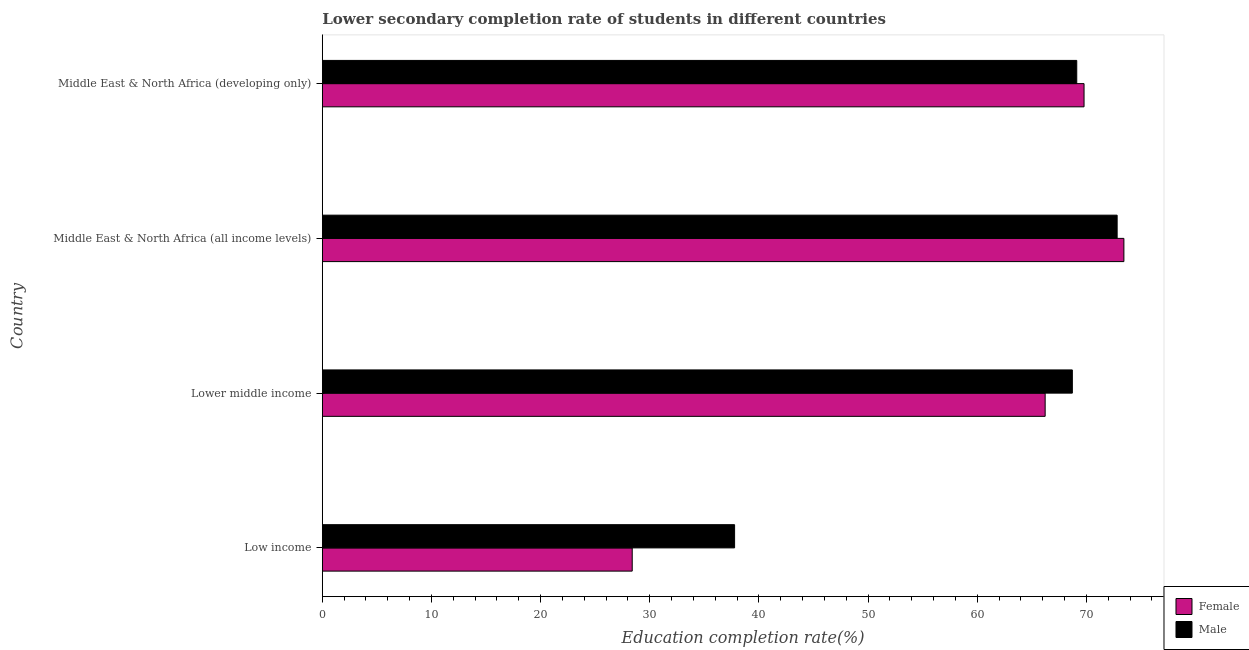Are the number of bars per tick equal to the number of legend labels?
Ensure brevity in your answer.  Yes. Are the number of bars on each tick of the Y-axis equal?
Your response must be concise. Yes. How many bars are there on the 4th tick from the bottom?
Provide a short and direct response. 2. What is the label of the 1st group of bars from the top?
Offer a very short reply. Middle East & North Africa (developing only). What is the education completion rate of female students in Middle East & North Africa (all income levels)?
Provide a succinct answer. 73.44. Across all countries, what is the maximum education completion rate of female students?
Make the answer very short. 73.44. Across all countries, what is the minimum education completion rate of male students?
Your answer should be compact. 37.77. In which country was the education completion rate of female students maximum?
Keep it short and to the point. Middle East & North Africa (all income levels). In which country was the education completion rate of female students minimum?
Your response must be concise. Low income. What is the total education completion rate of male students in the graph?
Keep it short and to the point. 248.42. What is the difference between the education completion rate of female students in Lower middle income and that in Middle East & North Africa (all income levels)?
Your response must be concise. -7.21. What is the difference between the education completion rate of female students in Middle East & North Africa (all income levels) and the education completion rate of male students in Low income?
Make the answer very short. 35.67. What is the average education completion rate of female students per country?
Make the answer very short. 59.46. What is the difference between the education completion rate of male students and education completion rate of female students in Lower middle income?
Make the answer very short. 2.49. What is the ratio of the education completion rate of male students in Middle East & North Africa (all income levels) to that in Middle East & North Africa (developing only)?
Give a very brief answer. 1.05. Is the education completion rate of male students in Middle East & North Africa (all income levels) less than that in Middle East & North Africa (developing only)?
Your answer should be very brief. No. Is the difference between the education completion rate of male students in Middle East & North Africa (all income levels) and Middle East & North Africa (developing only) greater than the difference between the education completion rate of female students in Middle East & North Africa (all income levels) and Middle East & North Africa (developing only)?
Give a very brief answer. Yes. What is the difference between the highest and the second highest education completion rate of female students?
Make the answer very short. 3.65. What is the difference between the highest and the lowest education completion rate of male students?
Offer a very short reply. 35.05. What does the 2nd bar from the bottom in Middle East & North Africa (all income levels) represents?
Your answer should be compact. Male. How many bars are there?
Ensure brevity in your answer.  8. Are the values on the major ticks of X-axis written in scientific E-notation?
Your answer should be very brief. No. Where does the legend appear in the graph?
Your answer should be very brief. Bottom right. How many legend labels are there?
Offer a very short reply. 2. How are the legend labels stacked?
Provide a succinct answer. Vertical. What is the title of the graph?
Make the answer very short. Lower secondary completion rate of students in different countries. Does "Investment in Transport" appear as one of the legend labels in the graph?
Your answer should be compact. No. What is the label or title of the X-axis?
Keep it short and to the point. Education completion rate(%). What is the label or title of the Y-axis?
Keep it short and to the point. Country. What is the Education completion rate(%) in Female in Low income?
Ensure brevity in your answer.  28.39. What is the Education completion rate(%) in Male in Low income?
Offer a very short reply. 37.77. What is the Education completion rate(%) of Female in Lower middle income?
Give a very brief answer. 66.22. What is the Education completion rate(%) of Male in Lower middle income?
Your response must be concise. 68.71. What is the Education completion rate(%) of Female in Middle East & North Africa (all income levels)?
Keep it short and to the point. 73.44. What is the Education completion rate(%) of Male in Middle East & North Africa (all income levels)?
Keep it short and to the point. 72.82. What is the Education completion rate(%) of Female in Middle East & North Africa (developing only)?
Your response must be concise. 69.78. What is the Education completion rate(%) in Male in Middle East & North Africa (developing only)?
Ensure brevity in your answer.  69.12. Across all countries, what is the maximum Education completion rate(%) in Female?
Provide a short and direct response. 73.44. Across all countries, what is the maximum Education completion rate(%) of Male?
Your answer should be compact. 72.82. Across all countries, what is the minimum Education completion rate(%) of Female?
Provide a short and direct response. 28.39. Across all countries, what is the minimum Education completion rate(%) of Male?
Make the answer very short. 37.77. What is the total Education completion rate(%) of Female in the graph?
Keep it short and to the point. 237.83. What is the total Education completion rate(%) in Male in the graph?
Ensure brevity in your answer.  248.42. What is the difference between the Education completion rate(%) of Female in Low income and that in Lower middle income?
Make the answer very short. -37.83. What is the difference between the Education completion rate(%) in Male in Low income and that in Lower middle income?
Provide a short and direct response. -30.94. What is the difference between the Education completion rate(%) in Female in Low income and that in Middle East & North Africa (all income levels)?
Give a very brief answer. -45.05. What is the difference between the Education completion rate(%) in Male in Low income and that in Middle East & North Africa (all income levels)?
Your answer should be very brief. -35.05. What is the difference between the Education completion rate(%) in Female in Low income and that in Middle East & North Africa (developing only)?
Make the answer very short. -41.39. What is the difference between the Education completion rate(%) in Male in Low income and that in Middle East & North Africa (developing only)?
Keep it short and to the point. -31.35. What is the difference between the Education completion rate(%) of Female in Lower middle income and that in Middle East & North Africa (all income levels)?
Keep it short and to the point. -7.21. What is the difference between the Education completion rate(%) of Male in Lower middle income and that in Middle East & North Africa (all income levels)?
Provide a short and direct response. -4.1. What is the difference between the Education completion rate(%) of Female in Lower middle income and that in Middle East & North Africa (developing only)?
Give a very brief answer. -3.56. What is the difference between the Education completion rate(%) in Male in Lower middle income and that in Middle East & North Africa (developing only)?
Keep it short and to the point. -0.4. What is the difference between the Education completion rate(%) of Female in Middle East & North Africa (all income levels) and that in Middle East & North Africa (developing only)?
Your answer should be compact. 3.65. What is the difference between the Education completion rate(%) of Male in Middle East & North Africa (all income levels) and that in Middle East & North Africa (developing only)?
Provide a succinct answer. 3.7. What is the difference between the Education completion rate(%) of Female in Low income and the Education completion rate(%) of Male in Lower middle income?
Make the answer very short. -40.32. What is the difference between the Education completion rate(%) of Female in Low income and the Education completion rate(%) of Male in Middle East & North Africa (all income levels)?
Your response must be concise. -44.43. What is the difference between the Education completion rate(%) of Female in Low income and the Education completion rate(%) of Male in Middle East & North Africa (developing only)?
Provide a succinct answer. -40.73. What is the difference between the Education completion rate(%) of Female in Lower middle income and the Education completion rate(%) of Male in Middle East & North Africa (all income levels)?
Your answer should be very brief. -6.6. What is the difference between the Education completion rate(%) in Female in Lower middle income and the Education completion rate(%) in Male in Middle East & North Africa (developing only)?
Provide a short and direct response. -2.89. What is the difference between the Education completion rate(%) in Female in Middle East & North Africa (all income levels) and the Education completion rate(%) in Male in Middle East & North Africa (developing only)?
Your answer should be very brief. 4.32. What is the average Education completion rate(%) of Female per country?
Offer a very short reply. 59.46. What is the average Education completion rate(%) of Male per country?
Your response must be concise. 62.1. What is the difference between the Education completion rate(%) in Female and Education completion rate(%) in Male in Low income?
Keep it short and to the point. -9.38. What is the difference between the Education completion rate(%) in Female and Education completion rate(%) in Male in Lower middle income?
Your answer should be compact. -2.49. What is the difference between the Education completion rate(%) of Female and Education completion rate(%) of Male in Middle East & North Africa (all income levels)?
Your answer should be very brief. 0.62. What is the difference between the Education completion rate(%) of Female and Education completion rate(%) of Male in Middle East & North Africa (developing only)?
Your answer should be compact. 0.67. What is the ratio of the Education completion rate(%) of Female in Low income to that in Lower middle income?
Give a very brief answer. 0.43. What is the ratio of the Education completion rate(%) in Male in Low income to that in Lower middle income?
Your answer should be compact. 0.55. What is the ratio of the Education completion rate(%) of Female in Low income to that in Middle East & North Africa (all income levels)?
Give a very brief answer. 0.39. What is the ratio of the Education completion rate(%) in Male in Low income to that in Middle East & North Africa (all income levels)?
Your answer should be very brief. 0.52. What is the ratio of the Education completion rate(%) in Female in Low income to that in Middle East & North Africa (developing only)?
Ensure brevity in your answer.  0.41. What is the ratio of the Education completion rate(%) in Male in Low income to that in Middle East & North Africa (developing only)?
Make the answer very short. 0.55. What is the ratio of the Education completion rate(%) of Female in Lower middle income to that in Middle East & North Africa (all income levels)?
Your answer should be compact. 0.9. What is the ratio of the Education completion rate(%) in Male in Lower middle income to that in Middle East & North Africa (all income levels)?
Give a very brief answer. 0.94. What is the ratio of the Education completion rate(%) of Female in Lower middle income to that in Middle East & North Africa (developing only)?
Ensure brevity in your answer.  0.95. What is the ratio of the Education completion rate(%) of Female in Middle East & North Africa (all income levels) to that in Middle East & North Africa (developing only)?
Ensure brevity in your answer.  1.05. What is the ratio of the Education completion rate(%) of Male in Middle East & North Africa (all income levels) to that in Middle East & North Africa (developing only)?
Ensure brevity in your answer.  1.05. What is the difference between the highest and the second highest Education completion rate(%) of Female?
Give a very brief answer. 3.65. What is the difference between the highest and the second highest Education completion rate(%) in Male?
Offer a terse response. 3.7. What is the difference between the highest and the lowest Education completion rate(%) in Female?
Your answer should be compact. 45.05. What is the difference between the highest and the lowest Education completion rate(%) of Male?
Offer a very short reply. 35.05. 